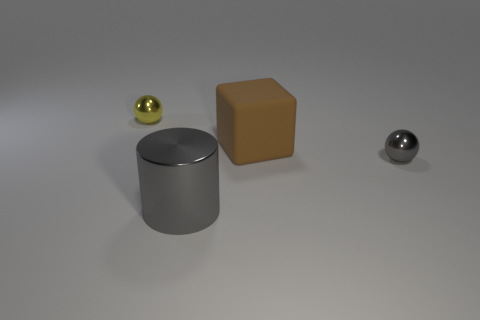There is a object that is the same color as the cylinder; what is its material?
Offer a very short reply. Metal. How many other things are there of the same color as the cylinder?
Your response must be concise. 1. There is a tiny metallic sphere to the right of the tiny yellow sphere; is its color the same as the large cylinder?
Make the answer very short. Yes. Do the small metal thing in front of the small yellow metal sphere and the small sphere behind the big matte cube have the same color?
Offer a very short reply. No. There is a brown cube; are there any tiny gray shiny balls on the right side of it?
Give a very brief answer. Yes. There is a thing that is behind the tiny gray ball and to the right of the large metallic cylinder; what color is it?
Make the answer very short. Brown. Is there a metallic object of the same color as the large shiny cylinder?
Keep it short and to the point. Yes. Is the material of the tiny sphere in front of the yellow object the same as the tiny sphere that is behind the big brown block?
Your answer should be compact. Yes. There is a ball on the right side of the yellow sphere; what is its size?
Your response must be concise. Small. The gray sphere has what size?
Keep it short and to the point. Small. 